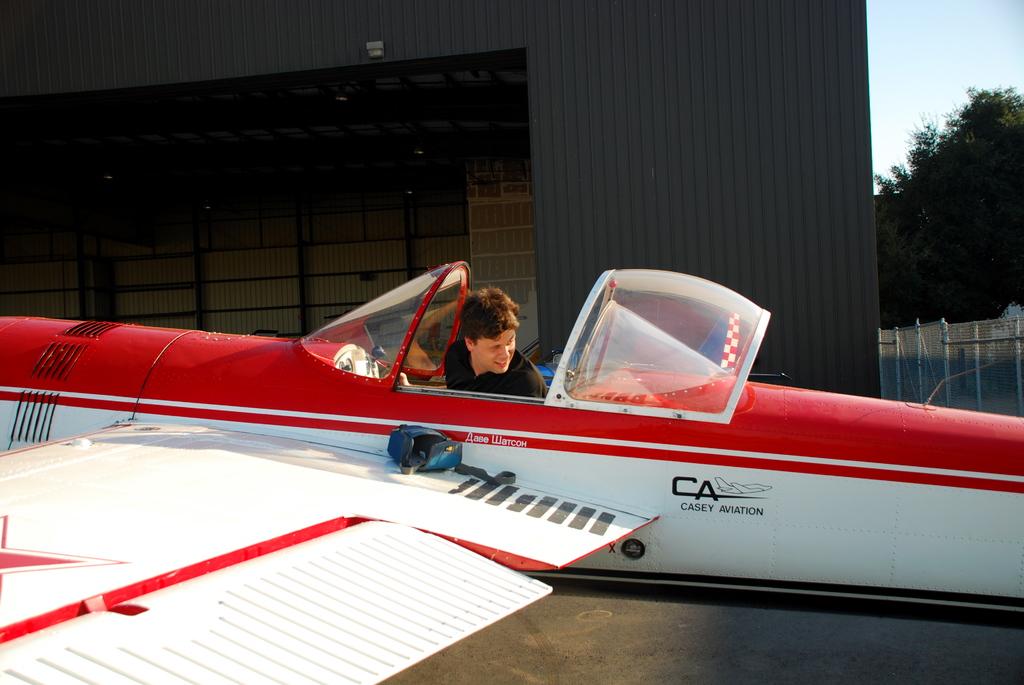What letters are painted on the side?
Provide a short and direct response. Ca. 